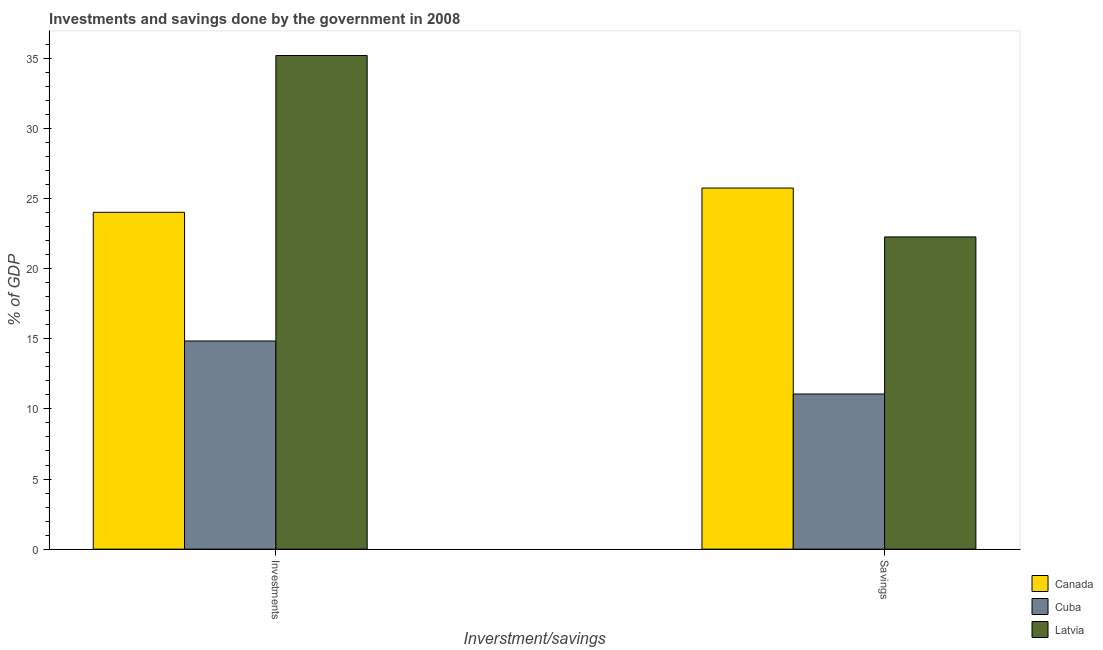How many groups of bars are there?
Give a very brief answer. 2. How many bars are there on the 2nd tick from the left?
Your response must be concise. 3. What is the label of the 2nd group of bars from the left?
Make the answer very short. Savings. What is the investments of government in Cuba?
Your answer should be compact. 14.84. Across all countries, what is the maximum savings of government?
Your response must be concise. 25.75. Across all countries, what is the minimum savings of government?
Your response must be concise. 11.06. In which country was the investments of government maximum?
Provide a succinct answer. Latvia. In which country was the savings of government minimum?
Offer a terse response. Cuba. What is the total savings of government in the graph?
Your answer should be compact. 59.08. What is the difference between the investments of government in Cuba and that in Canada?
Give a very brief answer. -9.18. What is the difference between the savings of government in Cuba and the investments of government in Canada?
Provide a short and direct response. -12.96. What is the average investments of government per country?
Provide a succinct answer. 24.69. What is the difference between the investments of government and savings of government in Cuba?
Your answer should be very brief. 3.78. What is the ratio of the savings of government in Canada to that in Cuba?
Your answer should be compact. 2.33. What does the 3rd bar from the left in Savings represents?
Provide a short and direct response. Latvia. What does the 1st bar from the right in Savings represents?
Offer a terse response. Latvia. Are all the bars in the graph horizontal?
Give a very brief answer. No. Are the values on the major ticks of Y-axis written in scientific E-notation?
Make the answer very short. No. Does the graph contain any zero values?
Your answer should be very brief. No. How many legend labels are there?
Keep it short and to the point. 3. What is the title of the graph?
Provide a short and direct response. Investments and savings done by the government in 2008. What is the label or title of the X-axis?
Your answer should be very brief. Inverstment/savings. What is the label or title of the Y-axis?
Offer a terse response. % of GDP. What is the % of GDP in Canada in Investments?
Ensure brevity in your answer.  24.02. What is the % of GDP of Cuba in Investments?
Provide a succinct answer. 14.84. What is the % of GDP in Latvia in Investments?
Your response must be concise. 35.2. What is the % of GDP in Canada in Savings?
Your response must be concise. 25.75. What is the % of GDP in Cuba in Savings?
Your answer should be compact. 11.06. What is the % of GDP of Latvia in Savings?
Offer a terse response. 22.27. Across all Inverstment/savings, what is the maximum % of GDP in Canada?
Provide a short and direct response. 25.75. Across all Inverstment/savings, what is the maximum % of GDP in Cuba?
Offer a very short reply. 14.84. Across all Inverstment/savings, what is the maximum % of GDP in Latvia?
Your answer should be compact. 35.2. Across all Inverstment/savings, what is the minimum % of GDP of Canada?
Offer a very short reply. 24.02. Across all Inverstment/savings, what is the minimum % of GDP in Cuba?
Give a very brief answer. 11.06. Across all Inverstment/savings, what is the minimum % of GDP of Latvia?
Offer a very short reply. 22.27. What is the total % of GDP in Canada in the graph?
Your response must be concise. 49.77. What is the total % of GDP of Cuba in the graph?
Make the answer very short. 25.91. What is the total % of GDP of Latvia in the graph?
Your answer should be very brief. 57.47. What is the difference between the % of GDP in Canada in Investments and that in Savings?
Provide a short and direct response. -1.73. What is the difference between the % of GDP in Cuba in Investments and that in Savings?
Offer a terse response. 3.78. What is the difference between the % of GDP in Latvia in Investments and that in Savings?
Give a very brief answer. 12.94. What is the difference between the % of GDP of Canada in Investments and the % of GDP of Cuba in Savings?
Your answer should be very brief. 12.96. What is the difference between the % of GDP in Canada in Investments and the % of GDP in Latvia in Savings?
Keep it short and to the point. 1.76. What is the difference between the % of GDP of Cuba in Investments and the % of GDP of Latvia in Savings?
Ensure brevity in your answer.  -7.42. What is the average % of GDP in Canada per Inverstment/savings?
Ensure brevity in your answer.  24.89. What is the average % of GDP of Cuba per Inverstment/savings?
Offer a terse response. 12.95. What is the average % of GDP of Latvia per Inverstment/savings?
Your answer should be very brief. 28.73. What is the difference between the % of GDP in Canada and % of GDP in Cuba in Investments?
Ensure brevity in your answer.  9.18. What is the difference between the % of GDP of Canada and % of GDP of Latvia in Investments?
Offer a very short reply. -11.18. What is the difference between the % of GDP in Cuba and % of GDP in Latvia in Investments?
Offer a very short reply. -20.36. What is the difference between the % of GDP in Canada and % of GDP in Cuba in Savings?
Make the answer very short. 14.69. What is the difference between the % of GDP of Canada and % of GDP of Latvia in Savings?
Offer a terse response. 3.49. What is the difference between the % of GDP of Cuba and % of GDP of Latvia in Savings?
Provide a short and direct response. -11.2. What is the ratio of the % of GDP of Canada in Investments to that in Savings?
Give a very brief answer. 0.93. What is the ratio of the % of GDP in Cuba in Investments to that in Savings?
Your response must be concise. 1.34. What is the ratio of the % of GDP of Latvia in Investments to that in Savings?
Give a very brief answer. 1.58. What is the difference between the highest and the second highest % of GDP in Canada?
Provide a short and direct response. 1.73. What is the difference between the highest and the second highest % of GDP in Cuba?
Offer a very short reply. 3.78. What is the difference between the highest and the second highest % of GDP in Latvia?
Ensure brevity in your answer.  12.94. What is the difference between the highest and the lowest % of GDP of Canada?
Offer a very short reply. 1.73. What is the difference between the highest and the lowest % of GDP of Cuba?
Make the answer very short. 3.78. What is the difference between the highest and the lowest % of GDP in Latvia?
Provide a succinct answer. 12.94. 